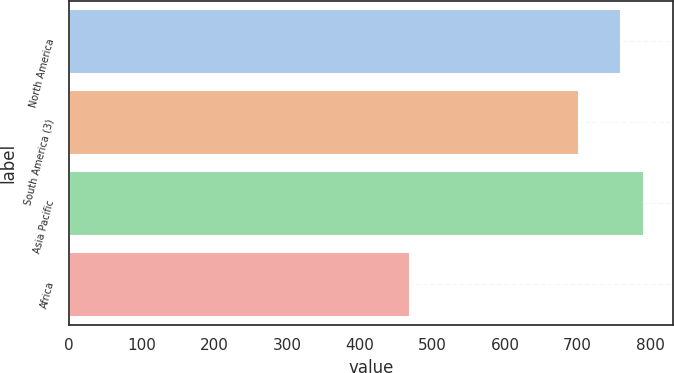Convert chart. <chart><loc_0><loc_0><loc_500><loc_500><bar_chart><fcel>North America<fcel>South America (3)<fcel>Asia Pacific<fcel>Africa<nl><fcel>760<fcel>702<fcel>791.9<fcel>470<nl></chart> 